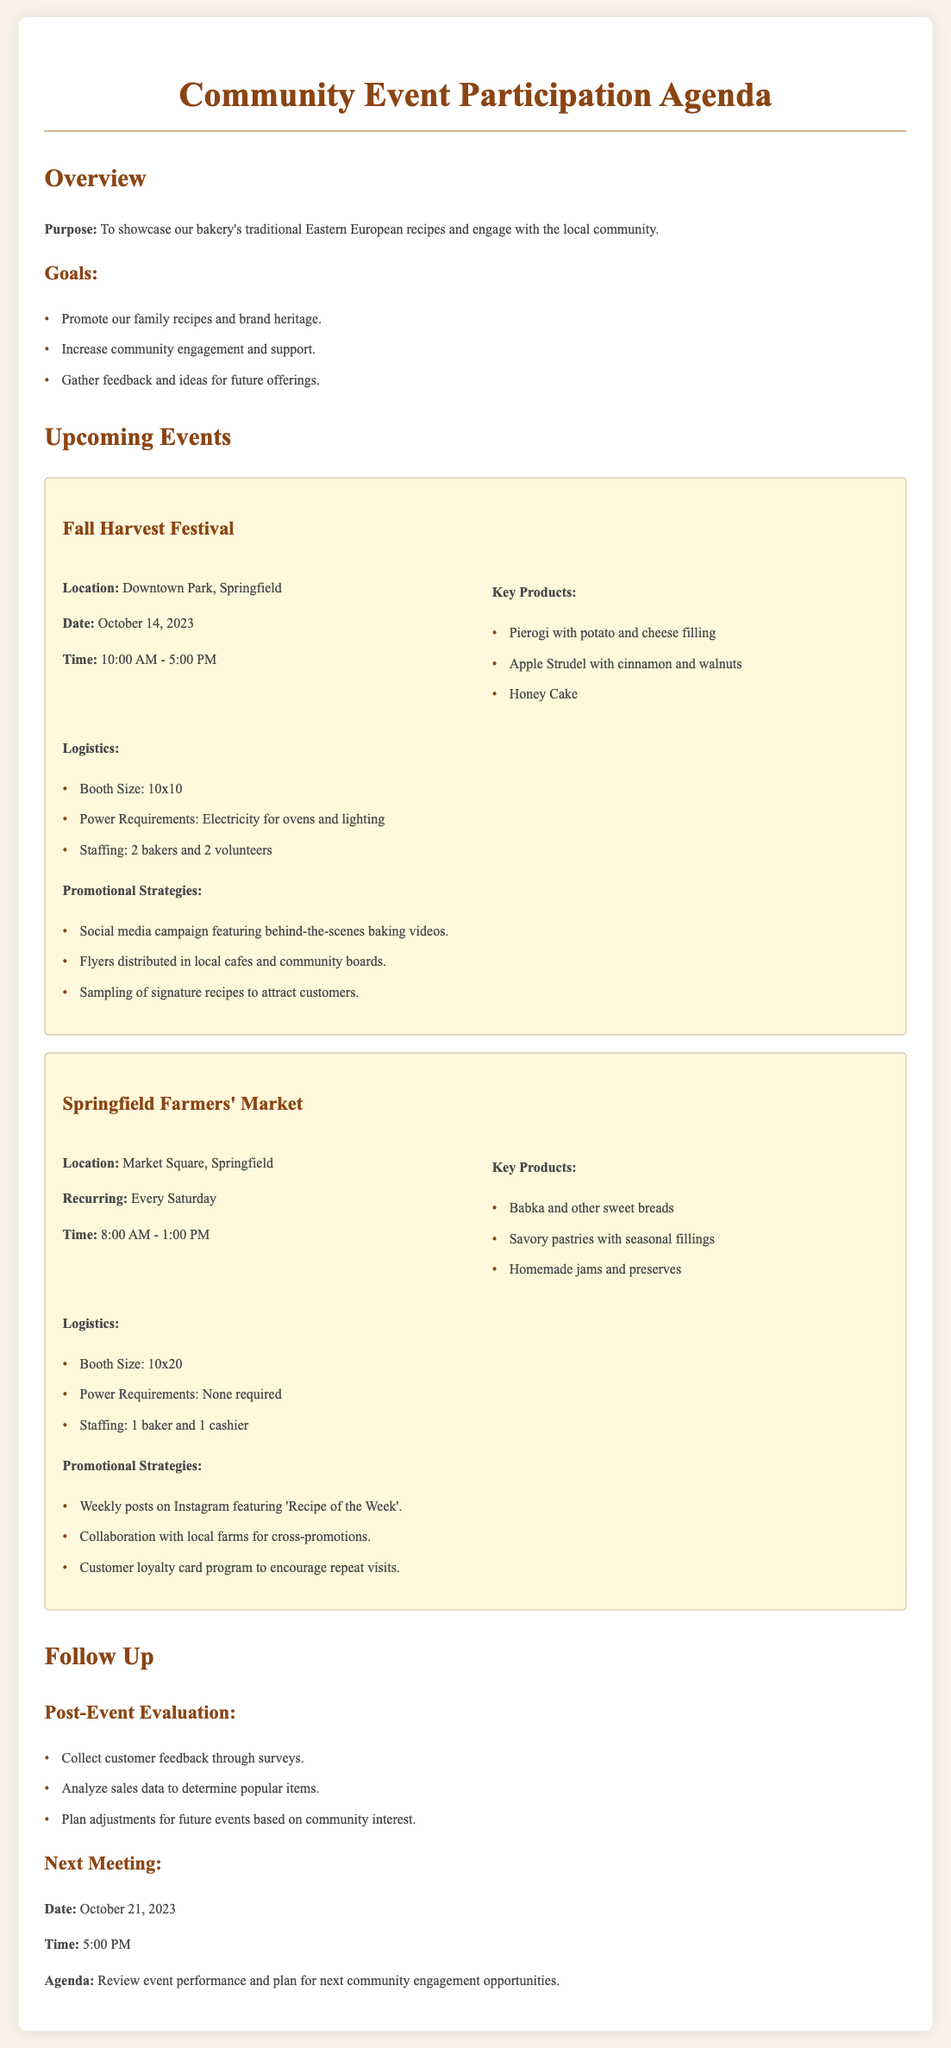What is the location of the Fall Harvest Festival? The location is mentioned under the Fall Harvest Festival section of the document as Downtown Park, Springfield.
Answer: Downtown Park, Springfield When is the Springfield Farmers' Market held? The document states that the Springfield Farmers' Market occurs every Saturday.
Answer: Every Saturday What is the booth size for the Fall Harvest Festival? The booth size for the Fall Harvest Festival is listed in the logistics section of the event details as 10x10.
Answer: 10x10 What product is mentioned as being available at the Springfield Farmers' Market? The document lists Babka and other sweet breads as a key product available at the Springfield Farmers' Market.
Answer: Babka and other sweet breads How many bakers are needed for the Fall Harvest Festival? The logistics section specifies that 2 bakers are needed for the Fall Harvest Festival.
Answer: 2 bakers What are the promotional strategies for the Springfield Farmers' Market? The document outlines several strategies, including weekly posts on Instagram featuring 'Recipe of the Week'.
Answer: Weekly posts on Instagram featuring 'Recipe of the Week' What date is the next meeting scheduled for? The date of the next meeting is stated in the follow-up section of the document as October 21, 2023.
Answer: October 21, 2023 How many volunteers will be present at the Fall Harvest Festival? According to the logistics for the Fall Harvest Festival, there will be 2 volunteers present.
Answer: 2 volunteers 